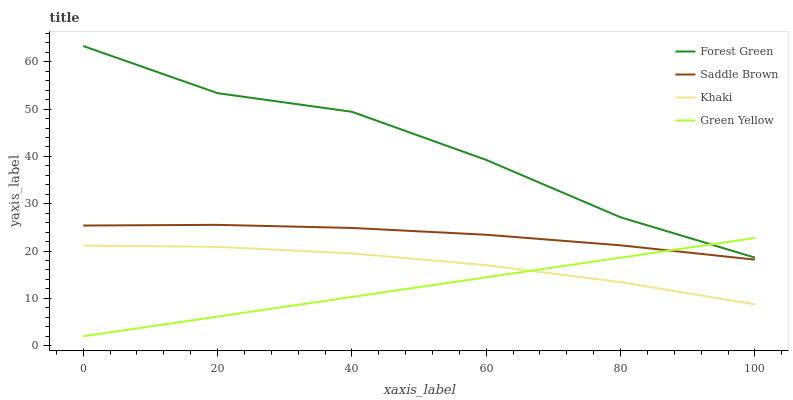Does Khaki have the minimum area under the curve?
Answer yes or no. No. Does Khaki have the maximum area under the curve?
Answer yes or no. No. Is Khaki the smoothest?
Answer yes or no. No. Is Khaki the roughest?
Answer yes or no. No. Does Khaki have the lowest value?
Answer yes or no. No. Does Khaki have the highest value?
Answer yes or no. No. Is Saddle Brown less than Forest Green?
Answer yes or no. Yes. Is Saddle Brown greater than Khaki?
Answer yes or no. Yes. Does Saddle Brown intersect Forest Green?
Answer yes or no. No. 